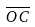<formula> <loc_0><loc_0><loc_500><loc_500>\overline { O C }</formula> 